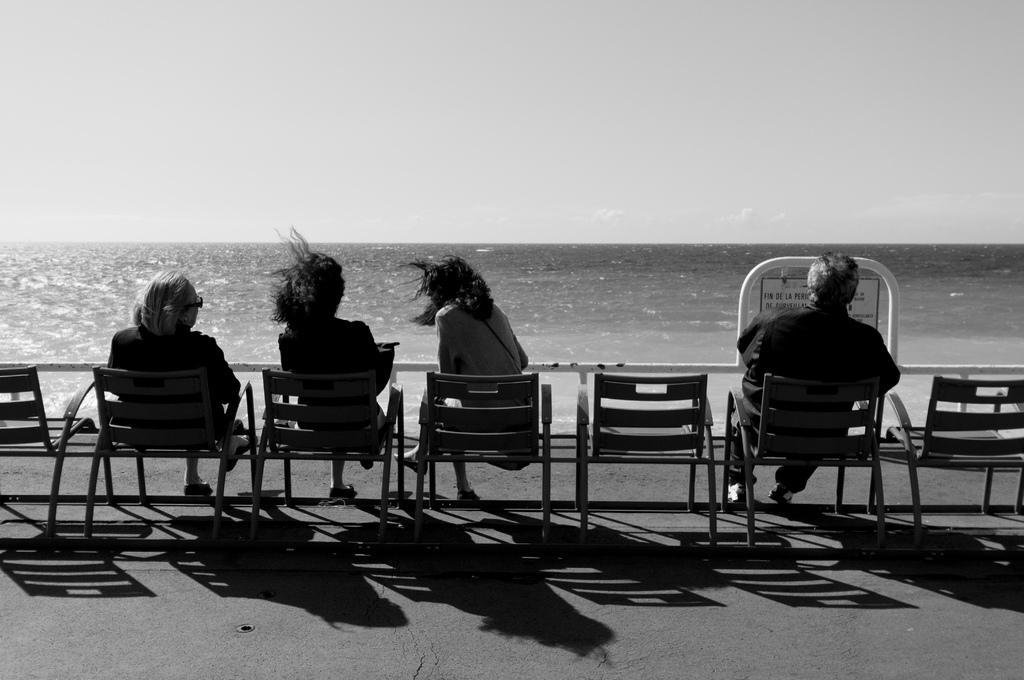In one or two sentences, can you explain what this image depicts? In this picture we can see four people one man and three women are sitting in chairs and looking at water, in the top of the image we can see sky. 